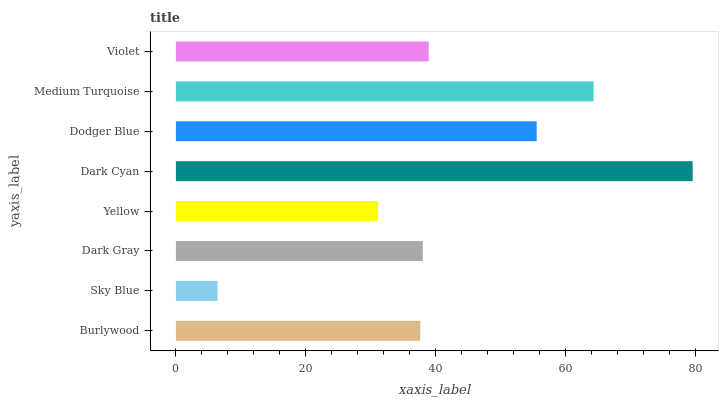Is Sky Blue the minimum?
Answer yes or no. Yes. Is Dark Cyan the maximum?
Answer yes or no. Yes. Is Dark Gray the minimum?
Answer yes or no. No. Is Dark Gray the maximum?
Answer yes or no. No. Is Dark Gray greater than Sky Blue?
Answer yes or no. Yes. Is Sky Blue less than Dark Gray?
Answer yes or no. Yes. Is Sky Blue greater than Dark Gray?
Answer yes or no. No. Is Dark Gray less than Sky Blue?
Answer yes or no. No. Is Violet the high median?
Answer yes or no. Yes. Is Dark Gray the low median?
Answer yes or no. Yes. Is Medium Turquoise the high median?
Answer yes or no. No. Is Yellow the low median?
Answer yes or no. No. 